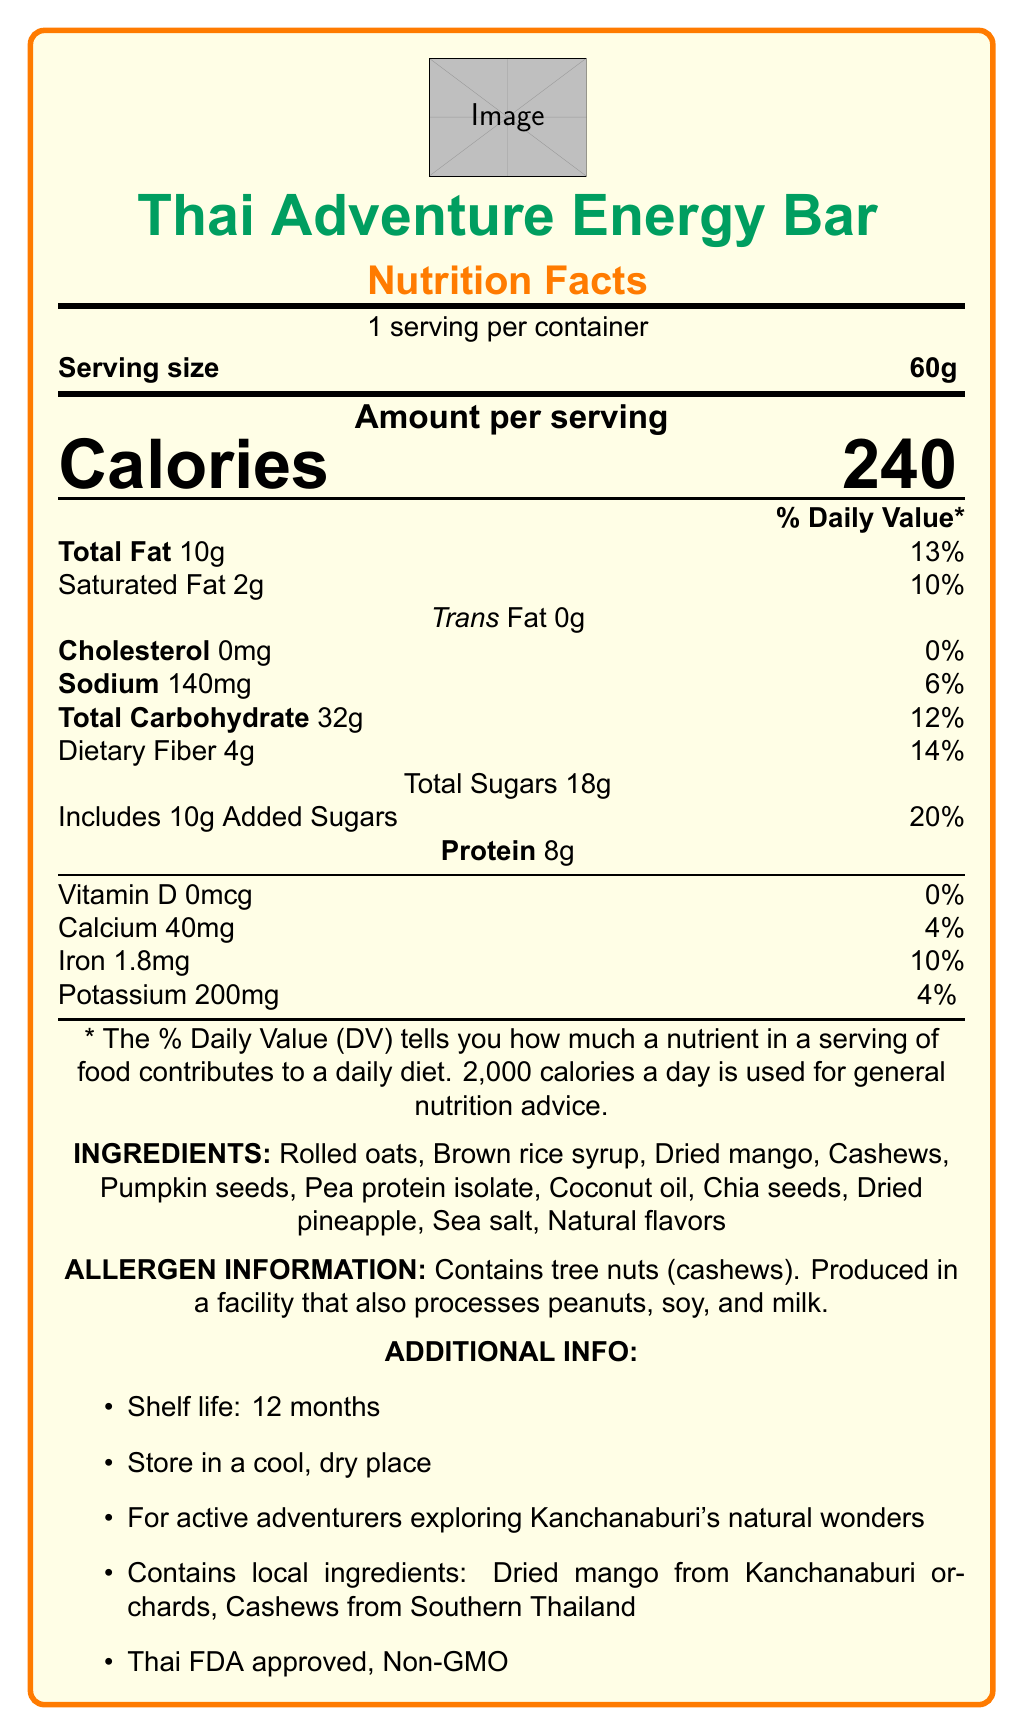What is the serving size of the Thai Adventure Energy Bar? The serving size is clearly listed as 60g in the Nutrition Facts section.
Answer: 60g How many calories are there per serving? The document lists the amount of calories per serving as 240 in the central part of the Nutrition Facts section.
Answer: 240 What is the total fat content in the energy bar? The total fat is given as 10g in the Nutrition Facts section of the document.
Answer: 10g How many grams of protein are in one serving of the Thai Adventure Energy Bar? The protein content is specified as 8g in the document.
Answer: 8g What local ingredients are used in the Thai Adventure Energy Bar? The additional info section lists the local ingredients.
Answer: Dried mango from Kanchanaburi orchards and cashews from Southern Thailand Which of the following nutrients has a 0% Daily Value? A. Iron B. Vitamin D C. Sodium D. Calcium Vitamin D has a 0% Daily Value as shown in the Nutrition Facts section.
Answer: B. Vitamin D What is the shelf life of the Thai Adventure Energy Bar? A. 6 months B. 12 months C. 24 months The shelf life is given as 12 months in the additional info section.
Answer: B. 12 months Is the Thai Adventure Energy Bar Non-GMO? Yes/No The document lists "Non-GMO" under the certifications in the additional info section.
Answer: Yes Summarize the main idea of the document. The document gives nutritional content per serving, lists ingredients, highlights local sourcing, shelf life, allergen warnings, and quality certifications, focusing on its target market of adventurers.
Answer: The document provides detailed nutritional information about the Thai Adventure Energy Bar, emphasizing its suitability for active adventurers, its local ingredients, shelf life, and allergen information, along with certifications like Thai FDA approval and being Non-GMO. What is the percentage of the Daily Value for dietary fiber in one serving? The Nutrition Facts section specifies that the Daily Value for dietary fiber is 14%.
Answer: 14% How many grams of added sugars are there in the bar? The document lists 10g of added sugars in the Nutrition Facts section.
Answer: 10g Does the Thai Adventure Energy Bar contain any trans fat? The document clearly states that the trans fat content is 0g.
Answer: No Which facility processes Tree Nuts (cashews), Peanuts, Soy, and Milk? The document states that the bar is produced in a facility that processes peanuts, soy, and milk, but does not specify the name of the facility.
Answer: The specific facility is not mentioned. Why might this energy bar be good for adventurers in Kanchanaburi? The description mentions that the energy bar is intended for active adventurers, citing its nutrient composition and the use of local ingredients.
Answer: The bar provides a convenient source of energy with local ingredients and crucial nutrients, making it ideal for active adventurers. What is the amount of iron in the Thai Adventure Energy Bar? The document lists 1.8mg of iron in the Nutrition Facts section.
Answer: 1.8mg Can you determine the exact price of the Thai Adventure Energy Bar from the document? The document does not provide any information about the price of the energy bar.
Answer: Not enough information 